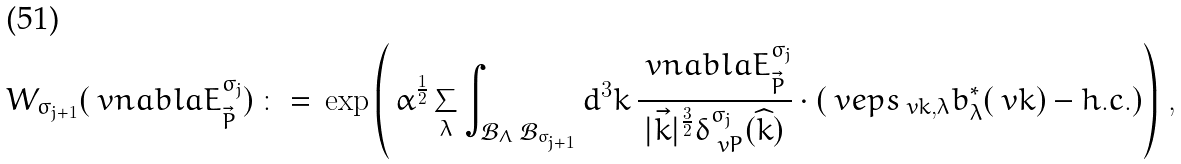Convert formula to latex. <formula><loc_0><loc_0><loc_500><loc_500>W _ { \sigma _ { j + 1 } } ( \ v n a b l a E _ { \vec { P } } ^ { \sigma _ { j } } ) \, \colon = \, \exp \left ( \, \alpha ^ { \frac { 1 } { 2 } } \sum _ { \lambda } \int _ { \mathcal { B } _ { \Lambda } \ \mathcal { B } _ { \sigma _ { j + 1 } } } d ^ { 3 } k \, \frac { \ v n a b l a E _ { \vec { P } } ^ { \sigma _ { j } } } { | \vec { k } | ^ { \frac { 3 } { 2 } } \delta _ { \ v P } ^ { \sigma _ { j } } ( \widehat { k } ) } \cdot ( \ v e p s _ { \ v k , \lambda } b _ { \lambda } ^ { * } ( \ v k ) - h . c . ) \right ) \, ,</formula> 